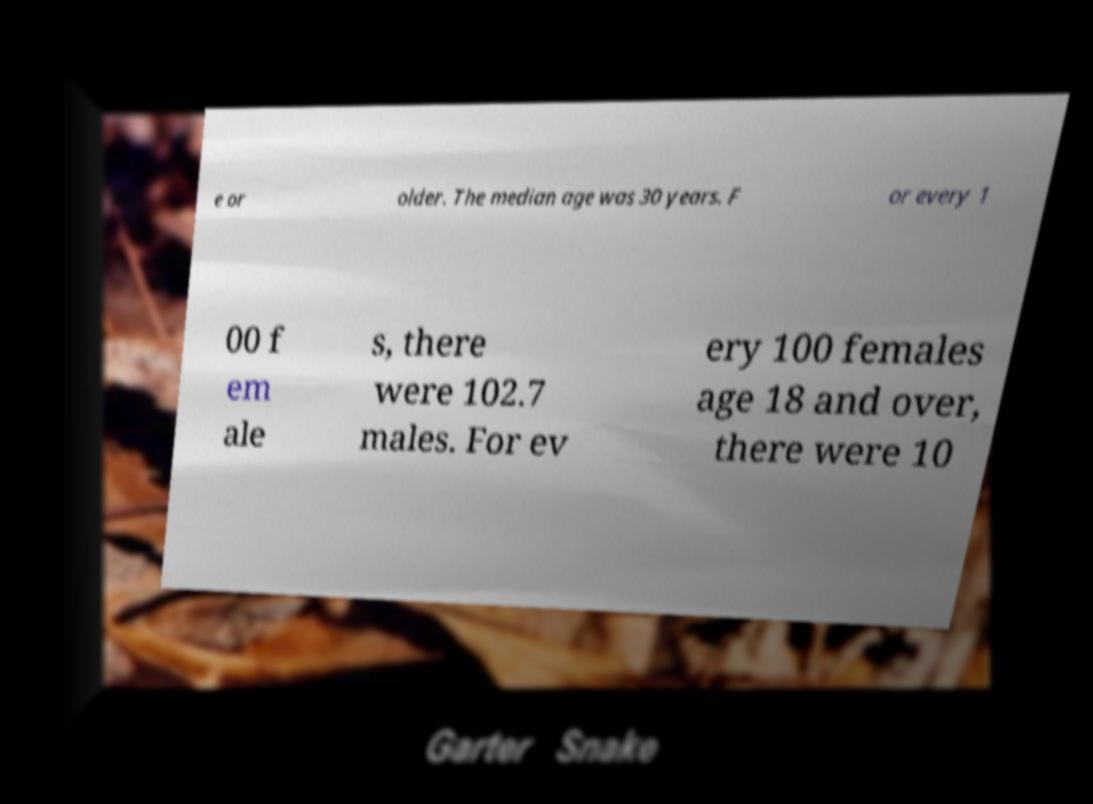I need the written content from this picture converted into text. Can you do that? e or older. The median age was 30 years. F or every 1 00 f em ale s, there were 102.7 males. For ev ery 100 females age 18 and over, there were 10 